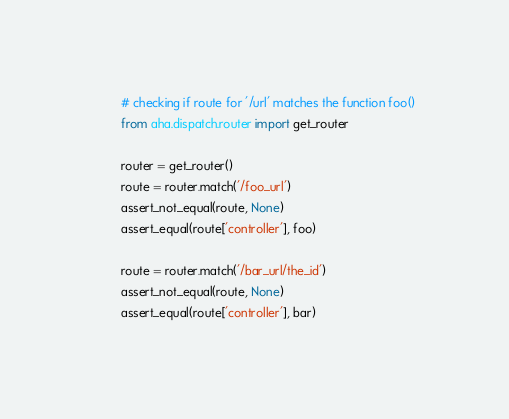Convert code to text. <code><loc_0><loc_0><loc_500><loc_500><_Python_>        # checking if route for '/url' matches the function foo()
        from aha.dispatch.router import get_router

        router = get_router()
        route = router.match('/foo_url')
        assert_not_equal(route, None)
        assert_equal(route['controller'], foo)

        route = router.match('/bar_url/the_id')
        assert_not_equal(route, None)
        assert_equal(route['controller'], bar)


</code> 